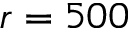<formula> <loc_0><loc_0><loc_500><loc_500>r = 5 0 0</formula> 